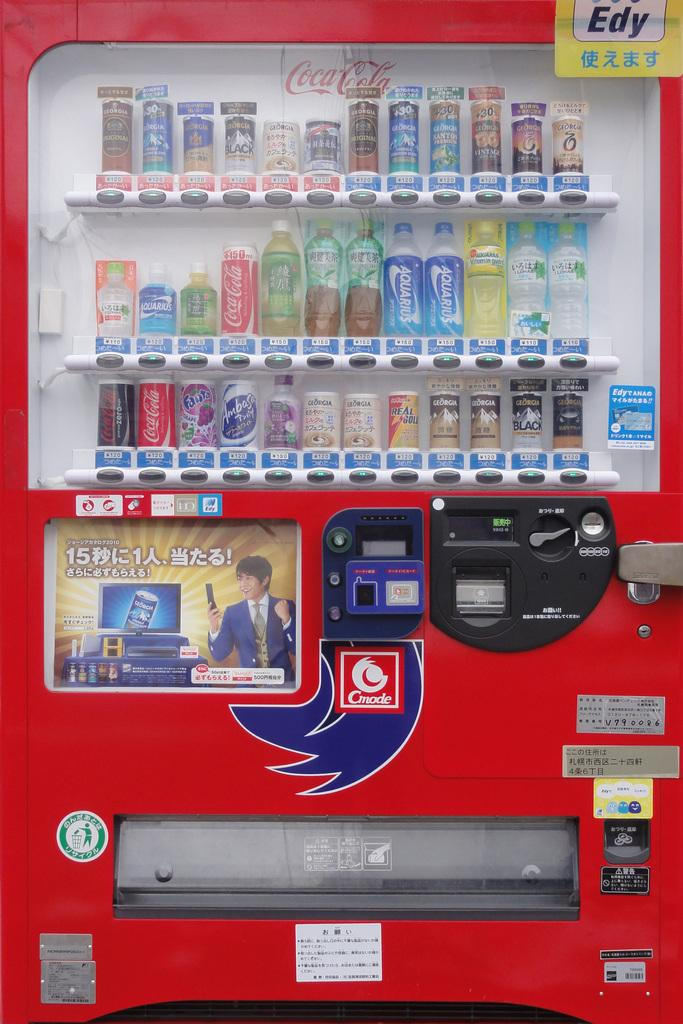<image>
Give a short and clear explanation of the subsequent image. a machine that has drinks in it that says 'coca-cola' in the back 